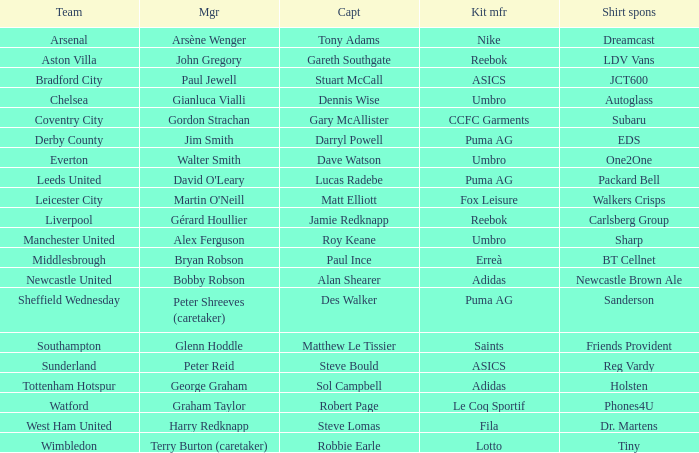Which shirt sponsor collaborates with nike for manufacturing kits? Dreamcast. 